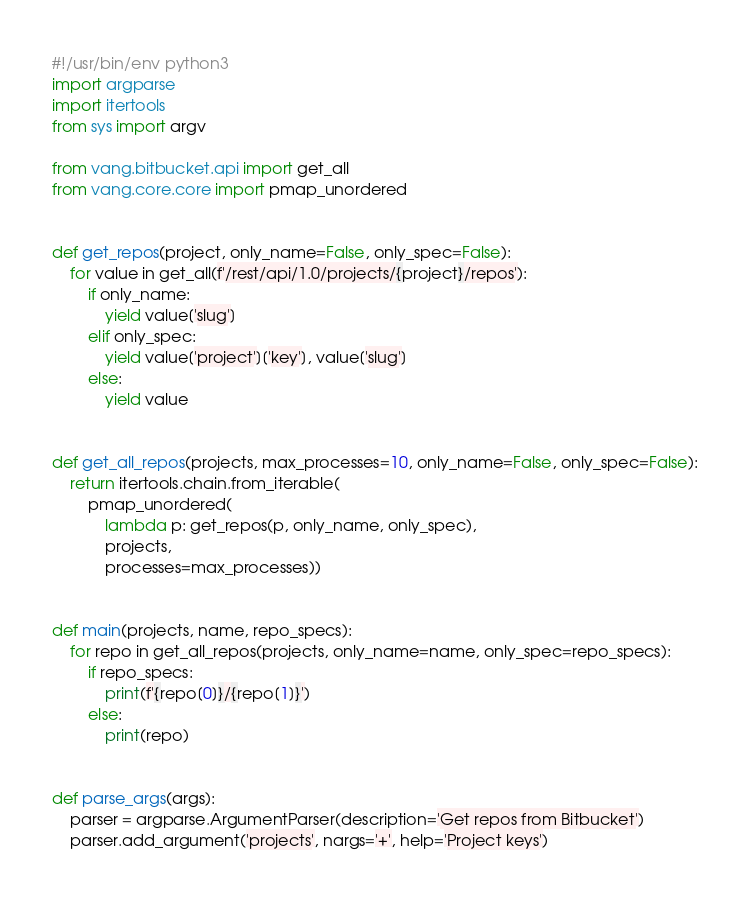Convert code to text. <code><loc_0><loc_0><loc_500><loc_500><_Python_>#!/usr/bin/env python3
import argparse
import itertools
from sys import argv

from vang.bitbucket.api import get_all
from vang.core.core import pmap_unordered


def get_repos(project, only_name=False, only_spec=False):
    for value in get_all(f'/rest/api/1.0/projects/{project}/repos'):
        if only_name:
            yield value['slug']
        elif only_spec:
            yield value['project']['key'], value['slug']
        else:
            yield value


def get_all_repos(projects, max_processes=10, only_name=False, only_spec=False):
    return itertools.chain.from_iterable(
        pmap_unordered(
            lambda p: get_repos(p, only_name, only_spec),
            projects,
            processes=max_processes))


def main(projects, name, repo_specs):
    for repo in get_all_repos(projects, only_name=name, only_spec=repo_specs):
        if repo_specs:
            print(f'{repo[0]}/{repo[1]}')
        else:
            print(repo)


def parse_args(args):
    parser = argparse.ArgumentParser(description='Get repos from Bitbucket')
    parser.add_argument('projects', nargs='+', help='Project keys')</code> 